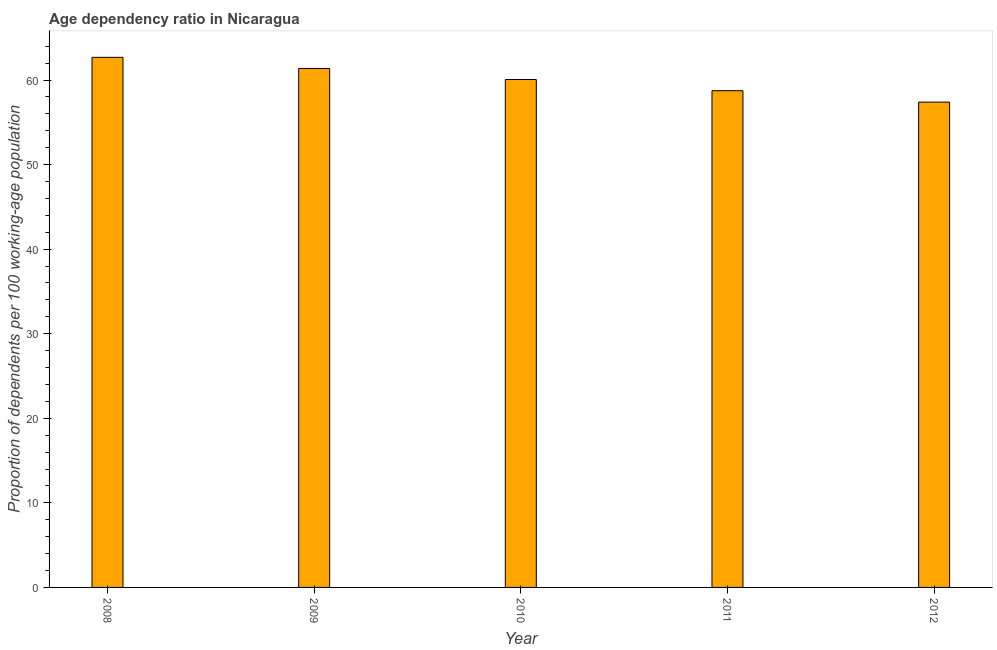What is the title of the graph?
Ensure brevity in your answer.  Age dependency ratio in Nicaragua. What is the label or title of the Y-axis?
Offer a very short reply. Proportion of dependents per 100 working-age population. What is the age dependency ratio in 2010?
Make the answer very short. 60.06. Across all years, what is the maximum age dependency ratio?
Offer a terse response. 62.68. Across all years, what is the minimum age dependency ratio?
Your answer should be compact. 57.39. In which year was the age dependency ratio minimum?
Offer a terse response. 2012. What is the sum of the age dependency ratio?
Your answer should be compact. 300.23. What is the difference between the age dependency ratio in 2009 and 2012?
Your answer should be very brief. 3.98. What is the average age dependency ratio per year?
Your answer should be compact. 60.05. What is the median age dependency ratio?
Offer a terse response. 60.06. What is the ratio of the age dependency ratio in 2010 to that in 2011?
Make the answer very short. 1.02. Is the age dependency ratio in 2008 less than that in 2009?
Offer a very short reply. No. Is the difference between the age dependency ratio in 2010 and 2011 greater than the difference between any two years?
Your response must be concise. No. What is the difference between the highest and the second highest age dependency ratio?
Keep it short and to the point. 1.31. What is the difference between the highest and the lowest age dependency ratio?
Your response must be concise. 5.29. Are all the bars in the graph horizontal?
Provide a succinct answer. No. How many years are there in the graph?
Your answer should be very brief. 5. What is the difference between two consecutive major ticks on the Y-axis?
Your answer should be very brief. 10. What is the Proportion of dependents per 100 working-age population in 2008?
Your response must be concise. 62.68. What is the Proportion of dependents per 100 working-age population in 2009?
Offer a terse response. 61.37. What is the Proportion of dependents per 100 working-age population of 2010?
Your answer should be very brief. 60.06. What is the Proportion of dependents per 100 working-age population in 2011?
Offer a terse response. 58.74. What is the Proportion of dependents per 100 working-age population in 2012?
Provide a short and direct response. 57.39. What is the difference between the Proportion of dependents per 100 working-age population in 2008 and 2009?
Make the answer very short. 1.32. What is the difference between the Proportion of dependents per 100 working-age population in 2008 and 2010?
Offer a terse response. 2.62. What is the difference between the Proportion of dependents per 100 working-age population in 2008 and 2011?
Your response must be concise. 3.94. What is the difference between the Proportion of dependents per 100 working-age population in 2008 and 2012?
Your answer should be very brief. 5.29. What is the difference between the Proportion of dependents per 100 working-age population in 2009 and 2010?
Make the answer very short. 1.31. What is the difference between the Proportion of dependents per 100 working-age population in 2009 and 2011?
Your response must be concise. 2.63. What is the difference between the Proportion of dependents per 100 working-age population in 2009 and 2012?
Your response must be concise. 3.98. What is the difference between the Proportion of dependents per 100 working-age population in 2010 and 2011?
Your answer should be compact. 1.32. What is the difference between the Proportion of dependents per 100 working-age population in 2010 and 2012?
Your answer should be compact. 2.67. What is the difference between the Proportion of dependents per 100 working-age population in 2011 and 2012?
Provide a short and direct response. 1.35. What is the ratio of the Proportion of dependents per 100 working-age population in 2008 to that in 2010?
Keep it short and to the point. 1.04. What is the ratio of the Proportion of dependents per 100 working-age population in 2008 to that in 2011?
Offer a very short reply. 1.07. What is the ratio of the Proportion of dependents per 100 working-age population in 2008 to that in 2012?
Keep it short and to the point. 1.09. What is the ratio of the Proportion of dependents per 100 working-age population in 2009 to that in 2010?
Ensure brevity in your answer.  1.02. What is the ratio of the Proportion of dependents per 100 working-age population in 2009 to that in 2011?
Keep it short and to the point. 1.04. What is the ratio of the Proportion of dependents per 100 working-age population in 2009 to that in 2012?
Ensure brevity in your answer.  1.07. What is the ratio of the Proportion of dependents per 100 working-age population in 2010 to that in 2012?
Your answer should be very brief. 1.05. What is the ratio of the Proportion of dependents per 100 working-age population in 2011 to that in 2012?
Offer a very short reply. 1.02. 